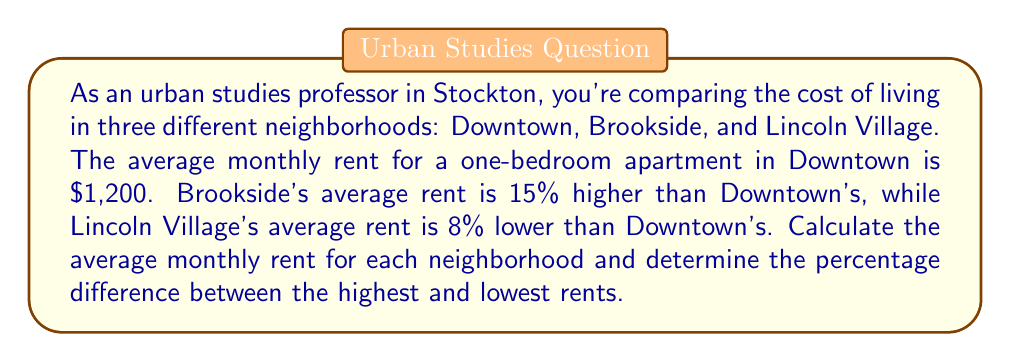Teach me how to tackle this problem. Let's approach this problem step-by-step:

1. Calculate the average rent for each neighborhood:

   Downtown: $1,200 (given)

   Brookside: 15% higher than Downtown
   $$1,200 + (1,200 \times 0.15) = 1,200 + 180 = $1,380$$

   Lincoln Village: 8% lower than Downtown
   $$1,200 - (1,200 \times 0.08) = 1,200 - 96 = $1,104$$

2. Identify the highest and lowest rents:
   Highest: Brookside at $1,380
   Lowest: Lincoln Village at $1,104

3. Calculate the percentage difference:
   $$\text{Percentage difference} = \frac{\text{Difference}}{\text{Lower value}} \times 100\%$$
   $$= \frac{1,380 - 1,104}{1,104} \times 100\%$$
   $$= \frac{276}{1,104} \times 100\%$$
   $$\approx 0.25 \times 100\% = 25\%$$
Answer: The average monthly rents are: Downtown $1,200, Brookside $1,380, and Lincoln Village $1,104. The percentage difference between the highest (Brookside) and lowest (Lincoln Village) rents is 25%. 